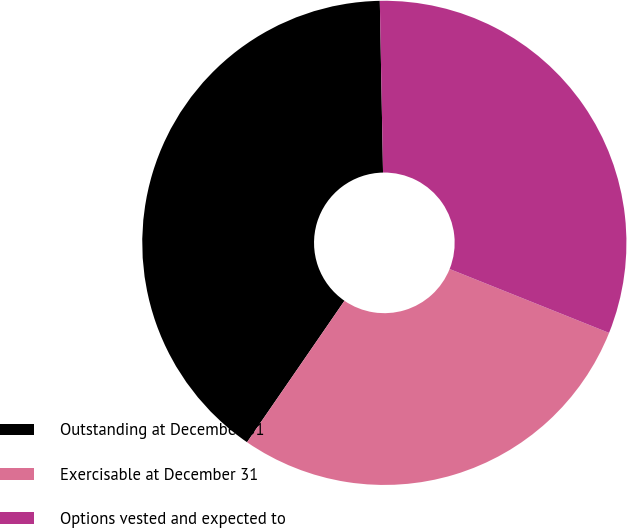<chart> <loc_0><loc_0><loc_500><loc_500><pie_chart><fcel>Outstanding at December 31<fcel>Exercisable at December 31<fcel>Options vested and expected to<nl><fcel>40.1%<fcel>28.53%<fcel>31.36%<nl></chart> 